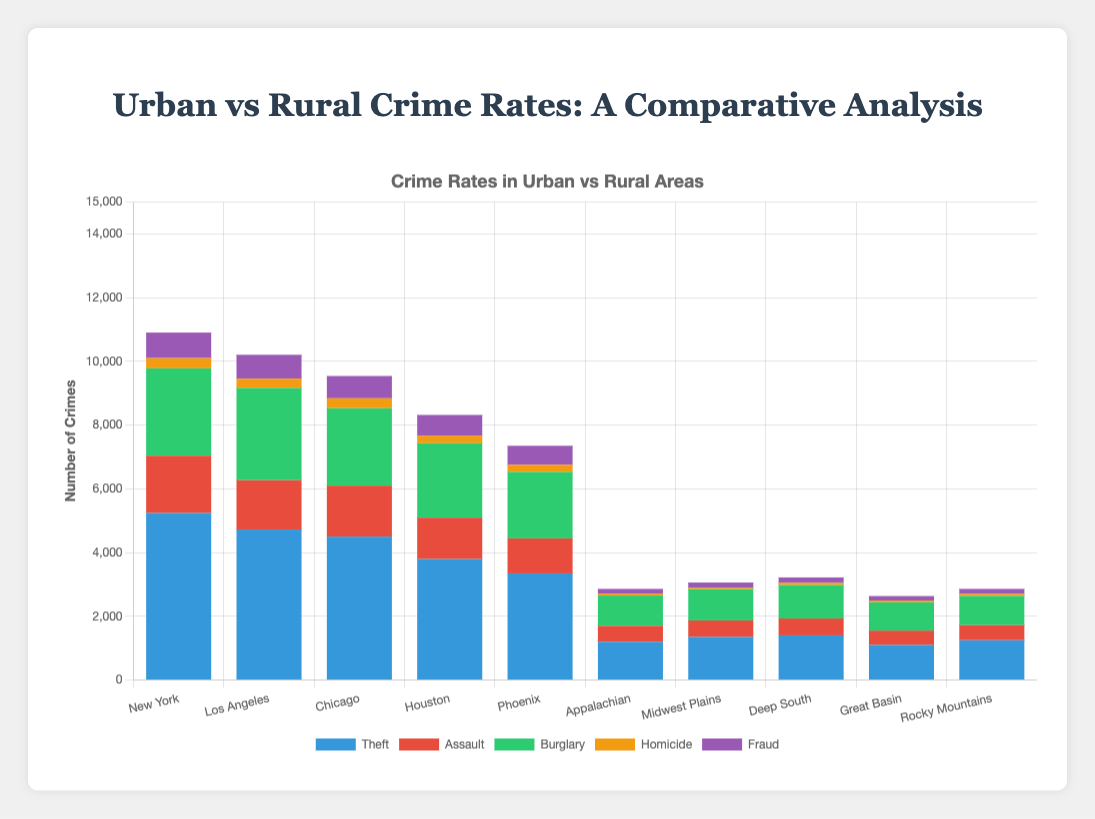What's the highest crime rate in theft among urban areas? Look at the height of the blue bars which represent 'Theft' in urban areas. The highest theft rate is in New York with 5240 incidents.
Answer: New York How does the total number of burglaries in Houston compare to that in Chicago? Compare the green bars representing 'Burglary' for Houston and Chicago. Houston has 2335 burglary incidents while Chicago has 2432. Chicago has more burglaries.
Answer: Chicago Which rural region has the highest number of homicides? Look at the yellow bars which represent 'Homicide' in rural regions. The Deep South has the highest number with 70 homicides.
Answer: Deep South Calculate the total number of criminal incidents in Phoenix. Sum the heights of all colored bars for Phoenix: 3345 (Theft) + 1100 (Assault) + 2087 (Burglary) + 220 (Homicide) + 600 (Fraud) = 7342.
Answer: 7342 In terms of fraud, how do rural areas compare to urban areas overall? Sum the purple bars for rural regions: 150+160+170+140+155 = 775. Sum purple bars for urban regions: 802+750+700+650+600 = 3502. Urban areas have significantly higher fraud incidents.
Answer: Urban areas have more fraud Which urban city has the lowest rate of assault? Look at the red bars for urban cities and compare their heights. Phoenix has the lowest assault rate with 1100 incidents.
Answer: Phoenix Given the data, which type of crime is consistently lower in rural regions compared to urban areas? Compare the heights of bars for each type of crime between urban and rural regions. All types are lower, but start with noticeable comparisons like theft and assault. Theft, assault, burglary, homicide, and fraud are all lower in rural areas compared to urban.
Answer: All types Calculate the average number of burglaries in rural regions. Add the burglary counts of all rural regions and divide by the number of rural entries: (950 + 980 + 1050 + 890 + 920) / 5 = 958.
Answer: 958 